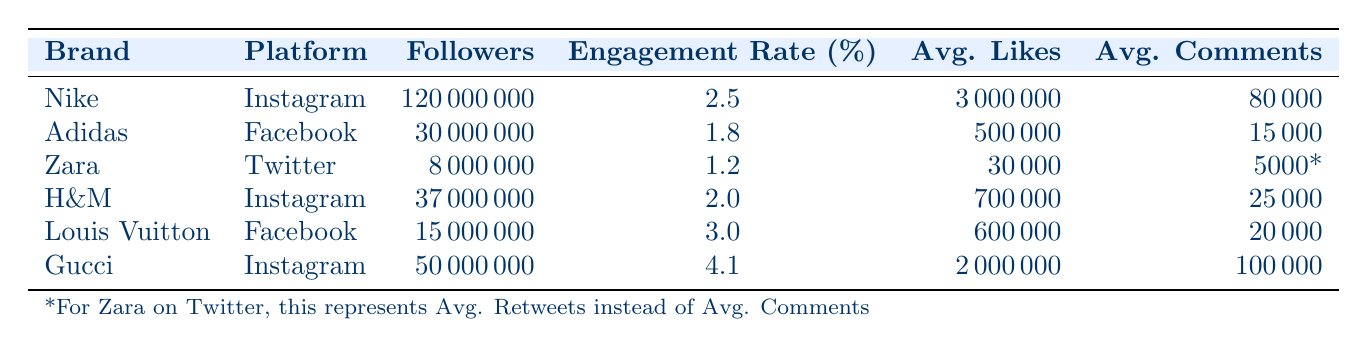What is the engagement rate of Gucci on Instagram? The table provides the engagement rate for each brand and platform. Gucci's entry shows an engagement rate of 4.1 percent on Instagram.
Answer: 4.1 Which brand has the highest number of followers on Instagram? Looking at the entries for Instagram, Nike has 120 million followers, while H&M has 37 million and Gucci has 50 million. Thus, Nike has the highest number of followers.
Answer: Nike How many more average likes does Nike receive compared to Louis Vuitton on Facebook? Nike has an average of 3 million likes on Instagram, while Louis Vuitton has an average of 600,000 likes on Facebook. The difference in likes is 3,000,000 - 600,000 = 2,400,000.
Answer: 2,400,000 Is it true that all brands on Instagram have an engagement rate above 2 percent? By checking the engagement rates on Instagram, Nike has 2.5 percent, H&M has 2.0 percent, and Gucci has 4.1 percent. H&M, with an engagement rate of 2.0 percent, is exactly at the threshold of 2 percent, making the statement false.
Answer: No What is the average engagement rate of brands across all platforms from the data? Engagement rates from the table are 2.5 (Nike) + 1.8 (Adidas) + 1.2 (Zara) + 2.0 (H&M) + 3.0 (Louis Vuitton) + 4.1 (Gucci) = 14.6. There are 6 brands, so the average is 14.6 / 6 = 2.43.
Answer: 2.43 